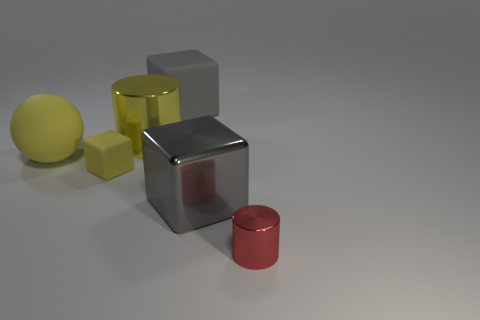Is the color of the big metal cube the same as the large matte block?
Your response must be concise. Yes. There is a block that is the same color as the large rubber ball; what is it made of?
Provide a succinct answer. Rubber. The small thing behind the cylinder that is in front of the small block is what shape?
Offer a very short reply. Cube. What number of other cylinders are made of the same material as the yellow cylinder?
Provide a short and direct response. 1. There is a small cube that is the same material as the large yellow ball; what is its color?
Your answer should be very brief. Yellow. There is a matte cube in front of the large yellow metal object behind the large object that is in front of the tiny block; what is its size?
Offer a terse response. Small. Are there fewer small metal things than matte objects?
Give a very brief answer. Yes. What color is the other matte object that is the same shape as the tiny yellow rubber thing?
Your answer should be compact. Gray. There is a large object that is to the right of the gray block that is behind the large metal cylinder; are there any big gray matte things right of it?
Your answer should be very brief. No. Is the shape of the tiny yellow rubber object the same as the small red metallic object?
Offer a very short reply. No. 